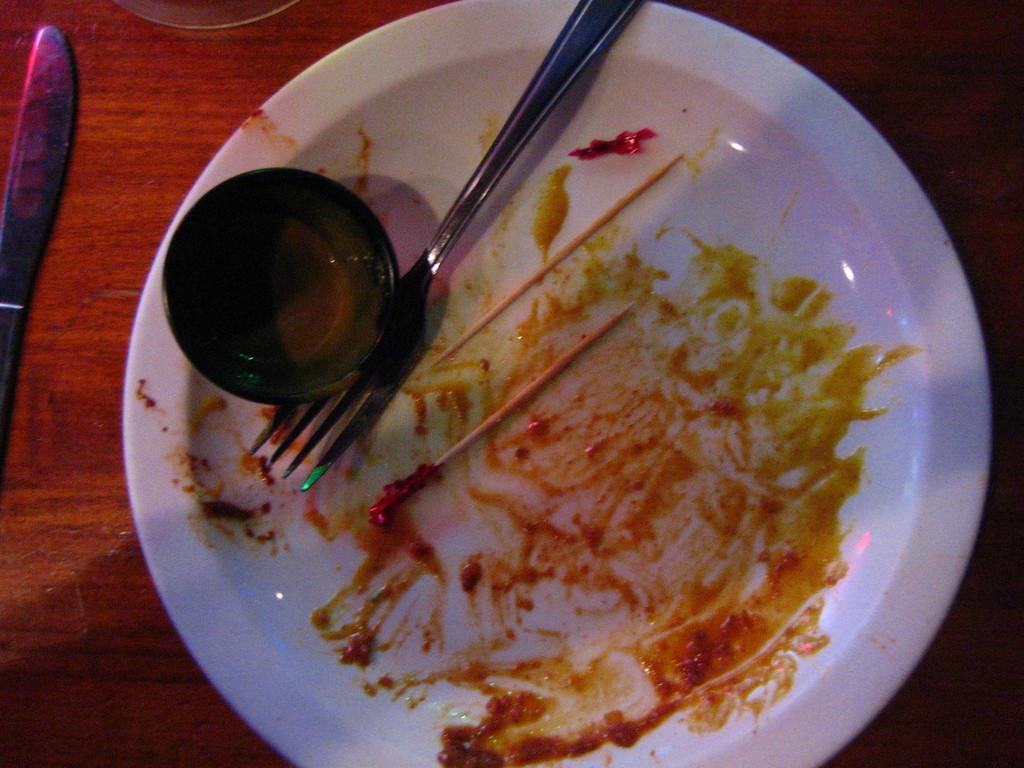In one or two sentences, can you explain what this image depicts? This image is taken indoors. At the bottom of the image there is a table. In the middle of the image there is a plate with a bowl, a spoon, toothpicks and sauce on it. On the left side of the image there is a knife on the table. 